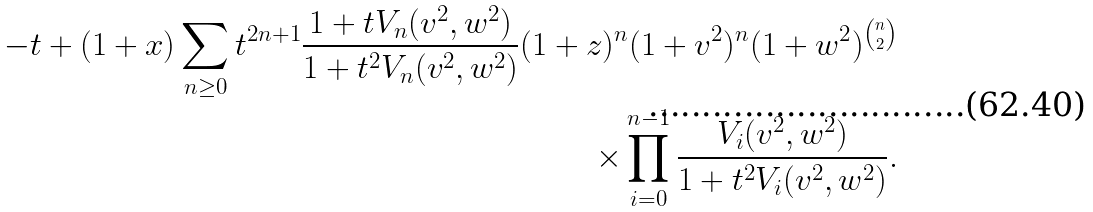<formula> <loc_0><loc_0><loc_500><loc_500>- t + ( 1 + x ) \sum _ { n \geq 0 } t ^ { 2 n + 1 } \frac { 1 + t V _ { n } ( v ^ { 2 } , w ^ { 2 } ) } { 1 + t ^ { 2 } V _ { n } ( v ^ { 2 } , w ^ { 2 } ) } ( 1 + z ) ^ { n } ( 1 + v ^ { 2 } ) ^ { n } ( 1 + w ^ { 2 } ) ^ { \binom { n } { 2 } } \\ \times \prod _ { i = 0 } ^ { n - 1 } \frac { V _ { i } ( v ^ { 2 } , w ^ { 2 } ) } { 1 + t ^ { 2 } V _ { i } ( v ^ { 2 } , w ^ { 2 } ) } .</formula> 